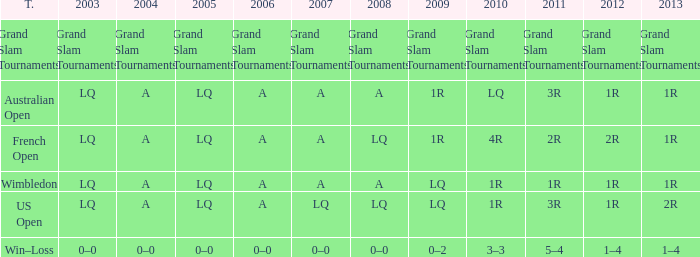Which year has a 2003 of lq? 1R, 1R, LQ, LQ. 